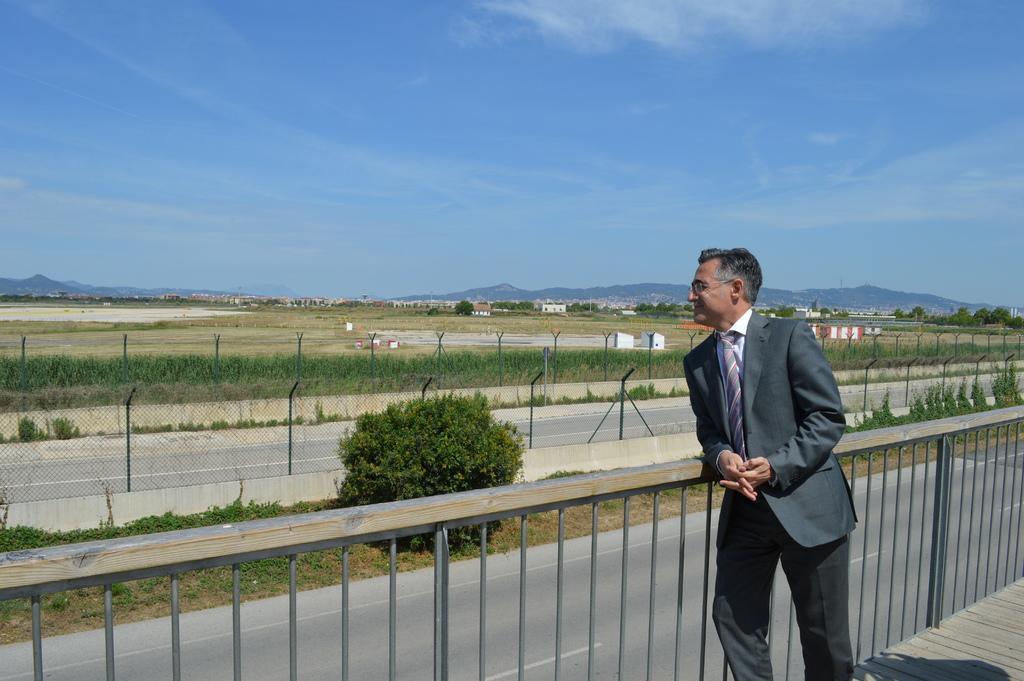Can you describe this image briefly? In this image, we can see a person standing. We can also see the fence. We can see the ground. We can see some grass, plants. There are a few houses. We can also see some trees. We can see the sky with clouds. 